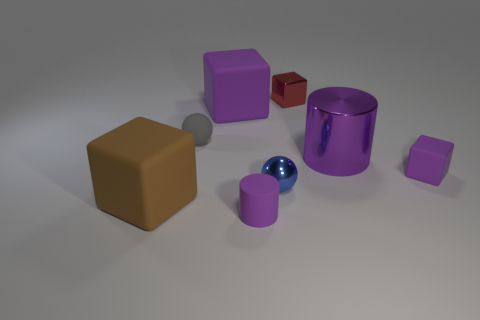There is a cylinder that is in front of the shiny object to the right of the small red object; is there a small block that is on the left side of it?
Keep it short and to the point. No. What is the color of the shiny cube?
Give a very brief answer. Red. Does the big matte thing in front of the matte sphere have the same shape as the tiny red object?
Provide a succinct answer. Yes. What number of objects are tiny blue shiny balls or things on the right side of the metal cube?
Provide a succinct answer. 3. Does the tiny cube on the right side of the red object have the same material as the big brown thing?
Your answer should be very brief. Yes. Is there any other thing that has the same size as the gray ball?
Ensure brevity in your answer.  Yes. There is a cylinder behind the block left of the gray rubber ball; what is it made of?
Ensure brevity in your answer.  Metal. Are there more purple shiny objects on the left side of the blue metal object than brown rubber blocks that are in front of the brown rubber thing?
Your response must be concise. No. What size is the gray sphere?
Your answer should be compact. Small. There is a big rubber cube left of the tiny gray matte thing; is it the same color as the tiny cylinder?
Your response must be concise. No. 